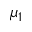Convert formula to latex. <formula><loc_0><loc_0><loc_500><loc_500>\mu _ { 1 }</formula> 